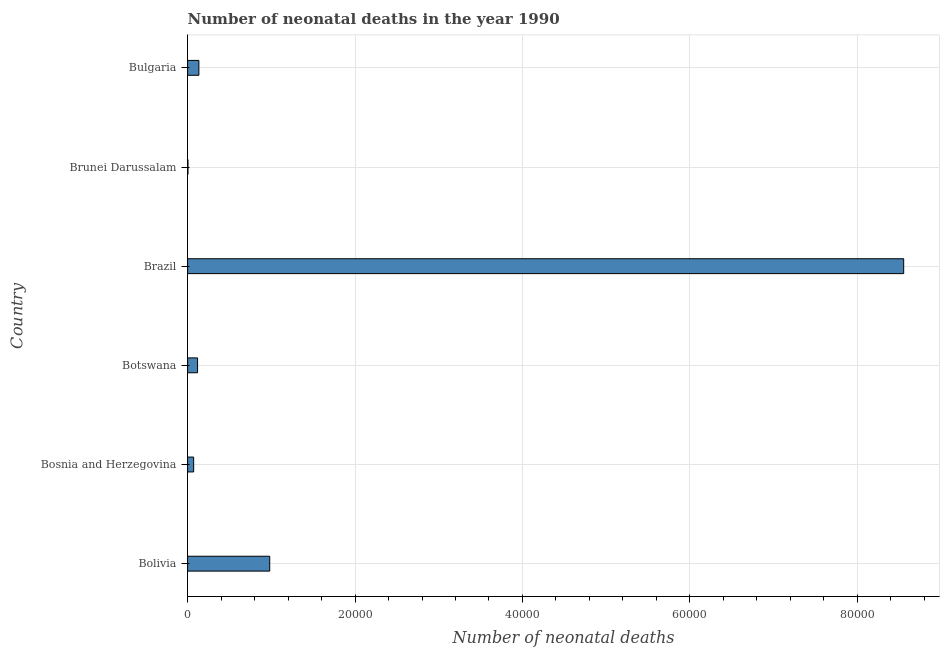Does the graph contain any zero values?
Make the answer very short. No. What is the title of the graph?
Provide a short and direct response. Number of neonatal deaths in the year 1990. What is the label or title of the X-axis?
Offer a terse response. Number of neonatal deaths. What is the number of neonatal deaths in Bolivia?
Offer a terse response. 9809. Across all countries, what is the maximum number of neonatal deaths?
Your answer should be very brief. 8.55e+04. Across all countries, what is the minimum number of neonatal deaths?
Make the answer very short. 46. In which country was the number of neonatal deaths maximum?
Your answer should be very brief. Brazil. In which country was the number of neonatal deaths minimum?
Offer a very short reply. Brunei Darussalam. What is the sum of the number of neonatal deaths?
Provide a short and direct response. 9.87e+04. What is the difference between the number of neonatal deaths in Brazil and Bulgaria?
Your answer should be compact. 8.42e+04. What is the average number of neonatal deaths per country?
Your response must be concise. 1.64e+04. What is the median number of neonatal deaths?
Keep it short and to the point. 1269.5. In how many countries, is the number of neonatal deaths greater than 12000 ?
Your answer should be very brief. 1. What is the ratio of the number of neonatal deaths in Brazil to that in Brunei Darussalam?
Keep it short and to the point. 1859.43. Is the difference between the number of neonatal deaths in Bosnia and Herzegovina and Botswana greater than the difference between any two countries?
Your response must be concise. No. What is the difference between the highest and the second highest number of neonatal deaths?
Your answer should be compact. 7.57e+04. What is the difference between the highest and the lowest number of neonatal deaths?
Provide a succinct answer. 8.55e+04. In how many countries, is the number of neonatal deaths greater than the average number of neonatal deaths taken over all countries?
Your response must be concise. 1. What is the difference between two consecutive major ticks on the X-axis?
Keep it short and to the point. 2.00e+04. What is the Number of neonatal deaths in Bolivia?
Offer a terse response. 9809. What is the Number of neonatal deaths in Bosnia and Herzegovina?
Your answer should be compact. 723. What is the Number of neonatal deaths of Botswana?
Provide a short and direct response. 1191. What is the Number of neonatal deaths of Brazil?
Your response must be concise. 8.55e+04. What is the Number of neonatal deaths of Bulgaria?
Offer a terse response. 1348. What is the difference between the Number of neonatal deaths in Bolivia and Bosnia and Herzegovina?
Your answer should be very brief. 9086. What is the difference between the Number of neonatal deaths in Bolivia and Botswana?
Provide a short and direct response. 8618. What is the difference between the Number of neonatal deaths in Bolivia and Brazil?
Your answer should be very brief. -7.57e+04. What is the difference between the Number of neonatal deaths in Bolivia and Brunei Darussalam?
Make the answer very short. 9763. What is the difference between the Number of neonatal deaths in Bolivia and Bulgaria?
Make the answer very short. 8461. What is the difference between the Number of neonatal deaths in Bosnia and Herzegovina and Botswana?
Your response must be concise. -468. What is the difference between the Number of neonatal deaths in Bosnia and Herzegovina and Brazil?
Ensure brevity in your answer.  -8.48e+04. What is the difference between the Number of neonatal deaths in Bosnia and Herzegovina and Brunei Darussalam?
Provide a succinct answer. 677. What is the difference between the Number of neonatal deaths in Bosnia and Herzegovina and Bulgaria?
Keep it short and to the point. -625. What is the difference between the Number of neonatal deaths in Botswana and Brazil?
Keep it short and to the point. -8.43e+04. What is the difference between the Number of neonatal deaths in Botswana and Brunei Darussalam?
Provide a short and direct response. 1145. What is the difference between the Number of neonatal deaths in Botswana and Bulgaria?
Provide a succinct answer. -157. What is the difference between the Number of neonatal deaths in Brazil and Brunei Darussalam?
Make the answer very short. 8.55e+04. What is the difference between the Number of neonatal deaths in Brazil and Bulgaria?
Your answer should be very brief. 8.42e+04. What is the difference between the Number of neonatal deaths in Brunei Darussalam and Bulgaria?
Your answer should be very brief. -1302. What is the ratio of the Number of neonatal deaths in Bolivia to that in Bosnia and Herzegovina?
Give a very brief answer. 13.57. What is the ratio of the Number of neonatal deaths in Bolivia to that in Botswana?
Your response must be concise. 8.24. What is the ratio of the Number of neonatal deaths in Bolivia to that in Brazil?
Your answer should be very brief. 0.12. What is the ratio of the Number of neonatal deaths in Bolivia to that in Brunei Darussalam?
Make the answer very short. 213.24. What is the ratio of the Number of neonatal deaths in Bolivia to that in Bulgaria?
Ensure brevity in your answer.  7.28. What is the ratio of the Number of neonatal deaths in Bosnia and Herzegovina to that in Botswana?
Keep it short and to the point. 0.61. What is the ratio of the Number of neonatal deaths in Bosnia and Herzegovina to that in Brazil?
Offer a very short reply. 0.01. What is the ratio of the Number of neonatal deaths in Bosnia and Herzegovina to that in Brunei Darussalam?
Your answer should be very brief. 15.72. What is the ratio of the Number of neonatal deaths in Bosnia and Herzegovina to that in Bulgaria?
Your answer should be very brief. 0.54. What is the ratio of the Number of neonatal deaths in Botswana to that in Brazil?
Your answer should be compact. 0.01. What is the ratio of the Number of neonatal deaths in Botswana to that in Brunei Darussalam?
Ensure brevity in your answer.  25.89. What is the ratio of the Number of neonatal deaths in Botswana to that in Bulgaria?
Offer a terse response. 0.88. What is the ratio of the Number of neonatal deaths in Brazil to that in Brunei Darussalam?
Keep it short and to the point. 1859.43. What is the ratio of the Number of neonatal deaths in Brazil to that in Bulgaria?
Ensure brevity in your answer.  63.45. What is the ratio of the Number of neonatal deaths in Brunei Darussalam to that in Bulgaria?
Make the answer very short. 0.03. 